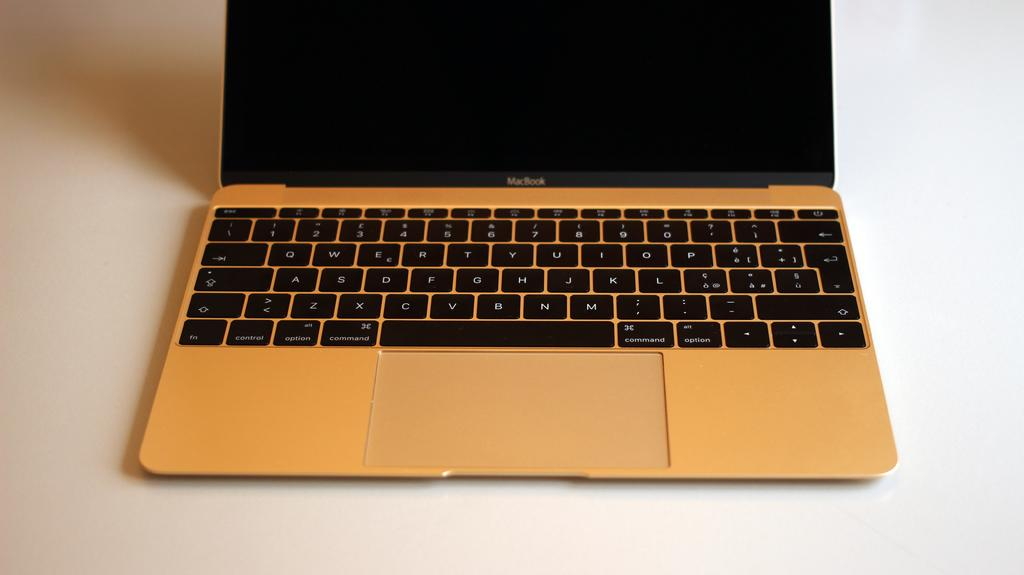Provide a one-sentence caption for the provided image. MacBook is written on this open laptop with a full keyboard ready for use. 